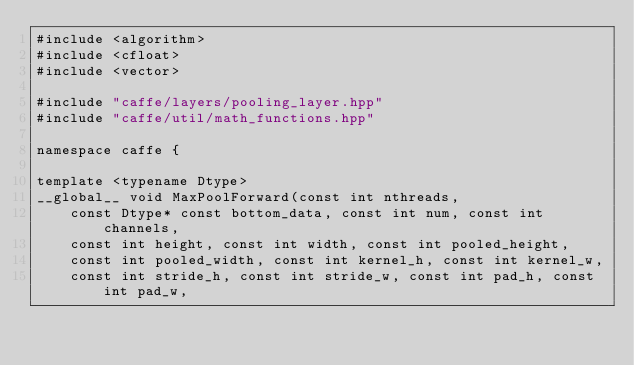<code> <loc_0><loc_0><loc_500><loc_500><_Cuda_>#include <algorithm>
#include <cfloat>
#include <vector>

#include "caffe/layers/pooling_layer.hpp"
#include "caffe/util/math_functions.hpp"

namespace caffe {

template <typename Dtype>
__global__ void MaxPoolForward(const int nthreads,
    const Dtype* const bottom_data, const int num, const int channels,
    const int height, const int width, const int pooled_height,
    const int pooled_width, const int kernel_h, const int kernel_w,
    const int stride_h, const int stride_w, const int pad_h, const int pad_w,</code> 